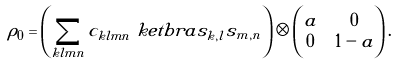Convert formula to latex. <formula><loc_0><loc_0><loc_500><loc_500>\rho _ { 0 } & = \left ( \sum _ { k l m n } c _ { k l m n } \ k e t b r a { s _ { k , l } } { s _ { m , n } } \right ) \otimes \begin{pmatrix} a & 0 \\ 0 & 1 - a \end{pmatrix} .</formula> 